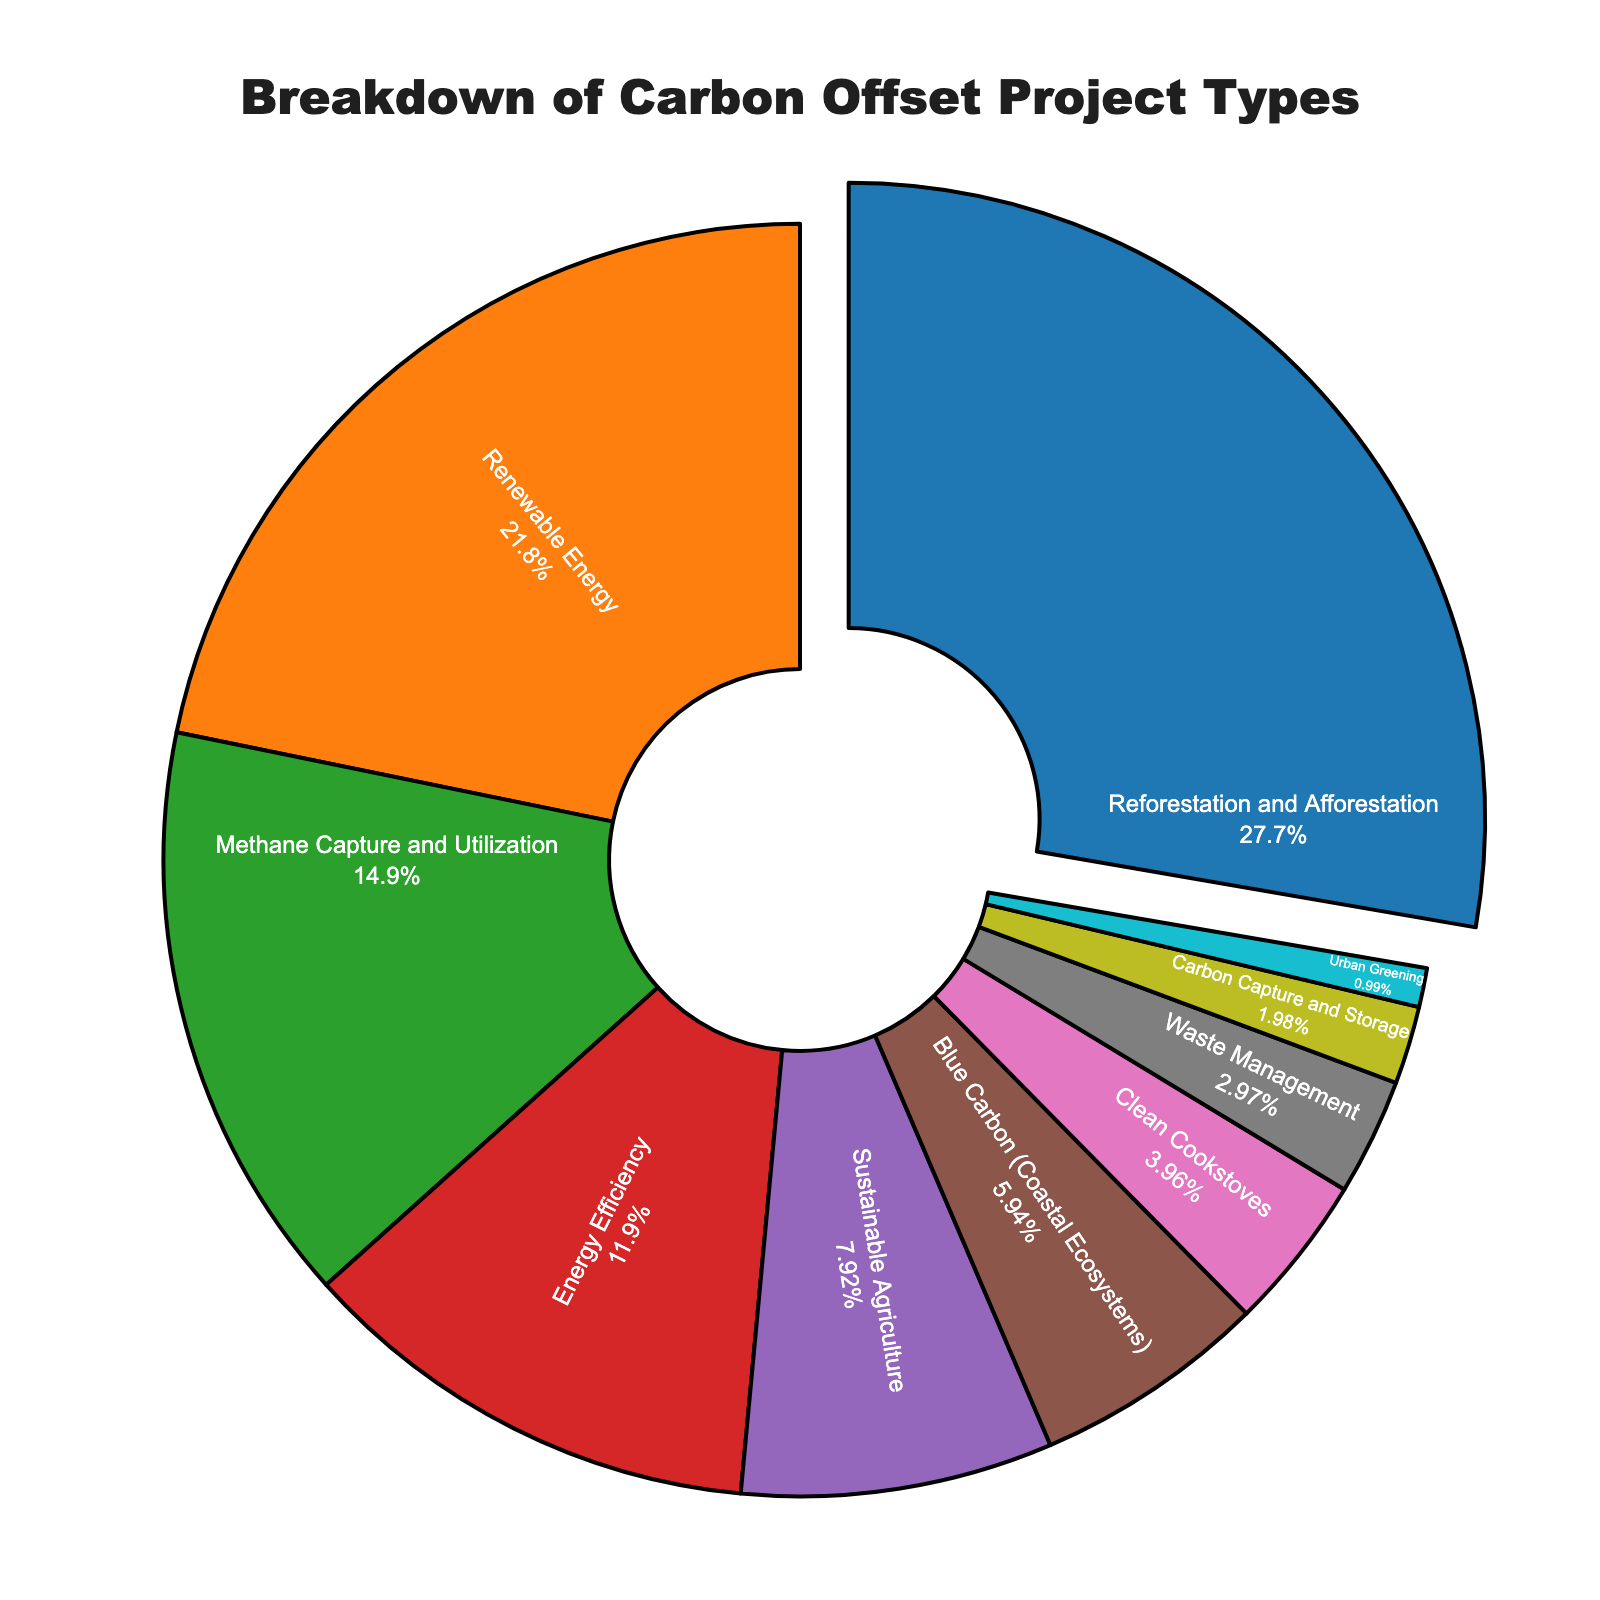What's the largest carbon offset project type by percentage? The pie chart visually indicates that the "Reforestation and Afforestation" sector has the largest section, which is 28%.
Answer: Reforestation and Afforestation Which project type has the smallest percentage? By looking at the sections of the pie chart, the smallest section is "Urban Greening" at 1%.
Answer: Urban Greening How much more percentage does Reforestation and Afforestation have compared to Clean Cookstoves? The percentage for Reforestation and Afforestation is 28% while for Clean Cookstoves it is 4%. So, 28% - 4% = 24%.
Answer: 24% What is the combined percentage of Energy Efficiency, Blue Carbon, and Waste Management? The percentages are 12% for Energy Efficiency, 6% for Blue Carbon, and 3% for Waste Management. So, the combined percentage is 12% + 6% + 3% = 21%.
Answer: 21% Are there more projects in the Renewable Energy category or the Combined Methane Capture and Utilization and Carbon Capture and Storage category? Renewable Energy is 22%, Methane Capture and Utilization is 15%, and Carbon Capture and Storage is 2%. Combined, Methane Capture and Utilization and Carbon Capture and Storage is 15% + 2% = 17%. Since 22% > 17%, there are more projects in the Renewable Energy category.
Answer: Renewable Energy Which project types together make up more than 50% of the total? Reforestation and Afforestation (28%) and Renewable Energy (22%) together equal 28% + 22% = 50%. Adding another sector like Methane Capture and Utilization (15%) results in 50% + 15% = 65%, which is more than 50%.
Answer: Reforestation and Afforestation, Renewable Energy, Methane Capture and Utilization Compare the percentages of Sustainable Agriculture and Urban Greening to find the ratio of their contributions. Sustainable Agriculture is 8% and Urban Greening is 1%. The ratio is 8% / 1% = 8:1
Answer: 8:1 How much percentage is accounted for by the lesser known project types, defined as those below 5%? The project types below 5% are Clean Cookstoves (4%), Waste Management (3%), and Urban Greening (1%). Their combined percentage is 4% + 3% + 1% = 8%.
Answer: 8% Which project type forms a greater percentage: Blue Carbon or Carbon Capture and Storage? Blue Carbon accounts for 6% while Carbon Capture and Storage accounts for 2%. Since 6% > 2%, Blue Carbon forms a greater percentage.
Answer: Blue Carbon 